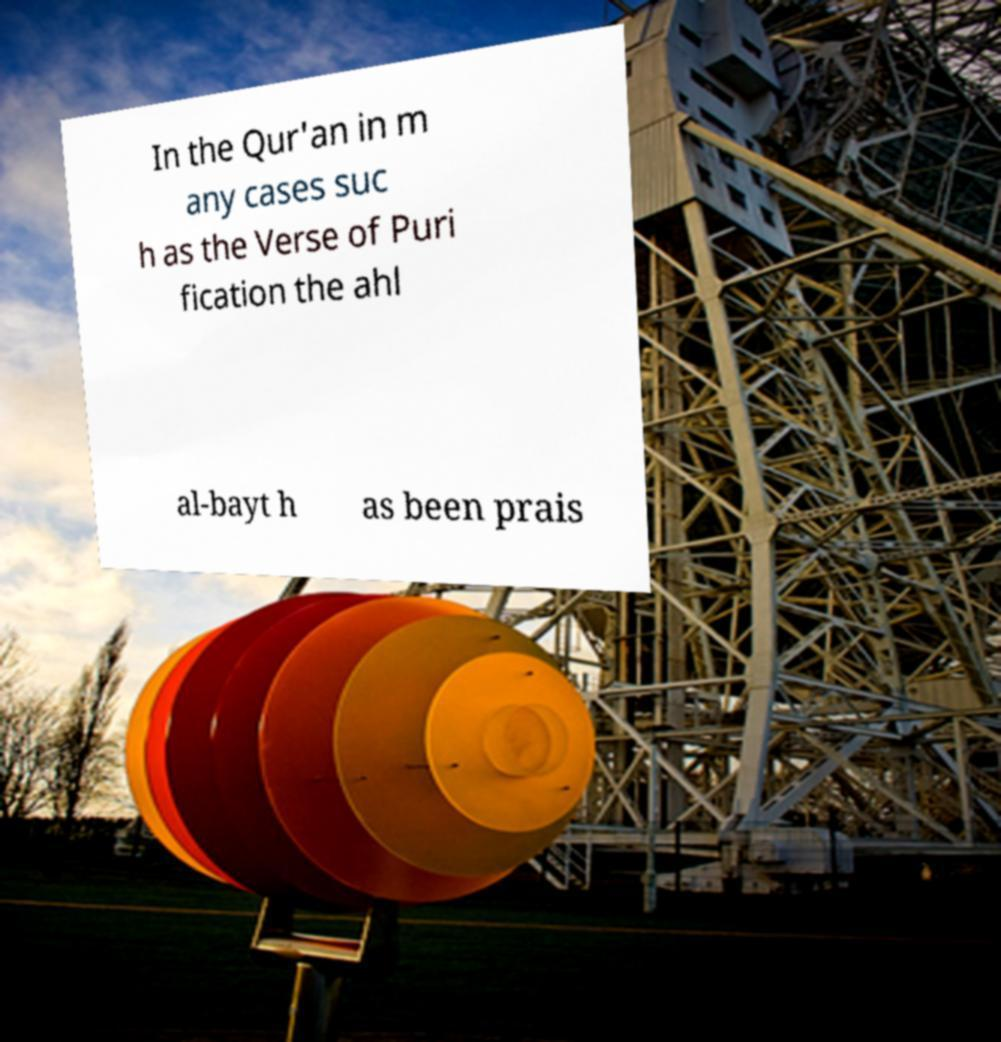Please identify and transcribe the text found in this image. In the Qur'an in m any cases suc h as the Verse of Puri fication the ahl al-bayt h as been prais 